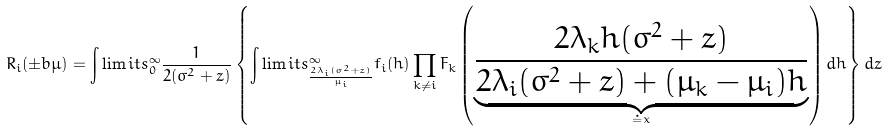Convert formula to latex. <formula><loc_0><loc_0><loc_500><loc_500>R _ { i } ( \pm b { \mu } ) = \int \lim i t s ^ { \infty } _ { 0 } \frac { 1 } { 2 ( \sigma ^ { 2 } + z ) } \left \{ \int \lim i t s ^ { \infty } _ { \frac { 2 \lambda _ { i } ( \sigma ^ { 2 } + z ) } { \mu _ { i } } } f _ { i } ( h ) \prod _ { k \not = i } F _ { k } \left ( \underbrace { \frac { 2 \lambda _ { k } h ( \sigma ^ { 2 } + z ) } { 2 \lambda _ { i } ( \sigma ^ { 2 } + z ) + ( \mu _ { k } - \mu _ { i } ) h } } _ { \doteq x } \right ) d h \right \} d z</formula> 